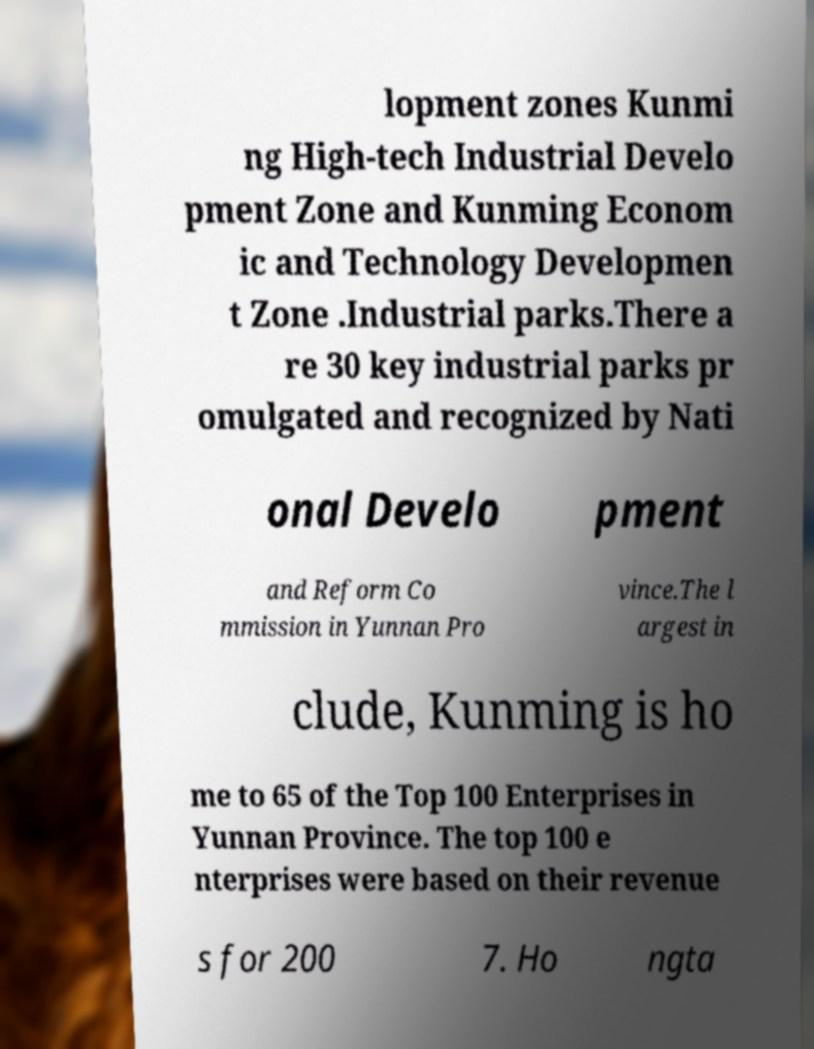Could you extract and type out the text from this image? lopment zones Kunmi ng High-tech Industrial Develo pment Zone and Kunming Econom ic and Technology Developmen t Zone .Industrial parks.There a re 30 key industrial parks pr omulgated and recognized by Nati onal Develo pment and Reform Co mmission in Yunnan Pro vince.The l argest in clude, Kunming is ho me to 65 of the Top 100 Enterprises in Yunnan Province. The top 100 e nterprises were based on their revenue s for 200 7. Ho ngta 